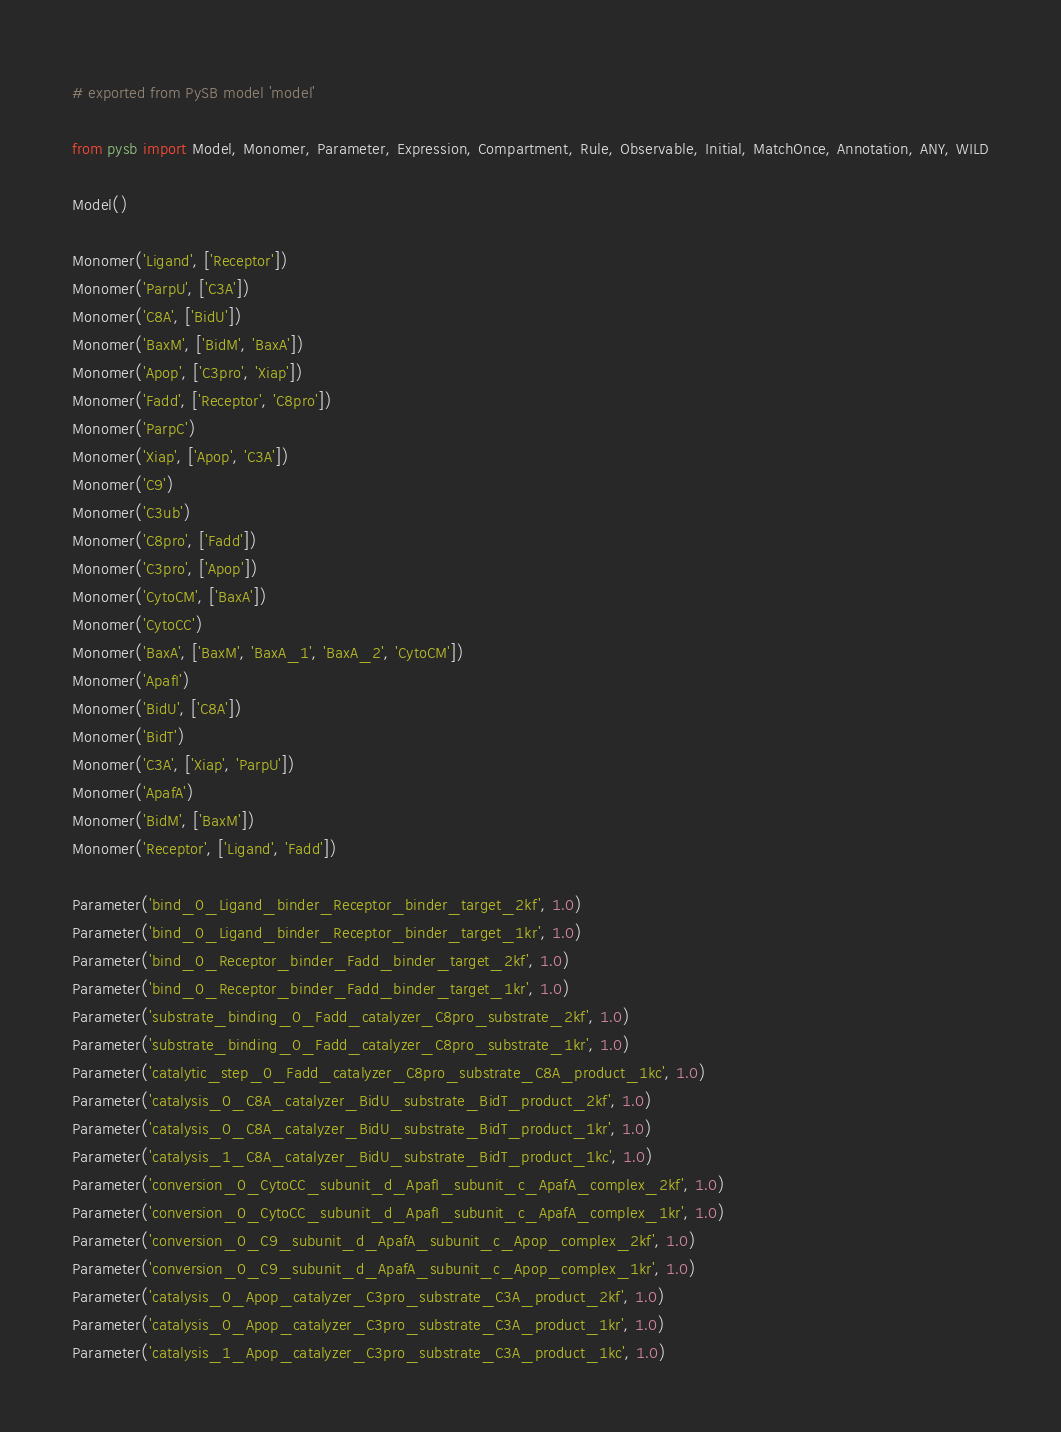<code> <loc_0><loc_0><loc_500><loc_500><_Python_># exported from PySB model 'model'

from pysb import Model, Monomer, Parameter, Expression, Compartment, Rule, Observable, Initial, MatchOnce, Annotation, ANY, WILD

Model()

Monomer('Ligand', ['Receptor'])
Monomer('ParpU', ['C3A'])
Monomer('C8A', ['BidU'])
Monomer('BaxM', ['BidM', 'BaxA'])
Monomer('Apop', ['C3pro', 'Xiap'])
Monomer('Fadd', ['Receptor', 'C8pro'])
Monomer('ParpC')
Monomer('Xiap', ['Apop', 'C3A'])
Monomer('C9')
Monomer('C3ub')
Monomer('C8pro', ['Fadd'])
Monomer('C3pro', ['Apop'])
Monomer('CytoCM', ['BaxA'])
Monomer('CytoCC')
Monomer('BaxA', ['BaxM', 'BaxA_1', 'BaxA_2', 'CytoCM'])
Monomer('ApafI')
Monomer('BidU', ['C8A'])
Monomer('BidT')
Monomer('C3A', ['Xiap', 'ParpU'])
Monomer('ApafA')
Monomer('BidM', ['BaxM'])
Monomer('Receptor', ['Ligand', 'Fadd'])

Parameter('bind_0_Ligand_binder_Receptor_binder_target_2kf', 1.0)
Parameter('bind_0_Ligand_binder_Receptor_binder_target_1kr', 1.0)
Parameter('bind_0_Receptor_binder_Fadd_binder_target_2kf', 1.0)
Parameter('bind_0_Receptor_binder_Fadd_binder_target_1kr', 1.0)
Parameter('substrate_binding_0_Fadd_catalyzer_C8pro_substrate_2kf', 1.0)
Parameter('substrate_binding_0_Fadd_catalyzer_C8pro_substrate_1kr', 1.0)
Parameter('catalytic_step_0_Fadd_catalyzer_C8pro_substrate_C8A_product_1kc', 1.0)
Parameter('catalysis_0_C8A_catalyzer_BidU_substrate_BidT_product_2kf', 1.0)
Parameter('catalysis_0_C8A_catalyzer_BidU_substrate_BidT_product_1kr', 1.0)
Parameter('catalysis_1_C8A_catalyzer_BidU_substrate_BidT_product_1kc', 1.0)
Parameter('conversion_0_CytoCC_subunit_d_ApafI_subunit_c_ApafA_complex_2kf', 1.0)
Parameter('conversion_0_CytoCC_subunit_d_ApafI_subunit_c_ApafA_complex_1kr', 1.0)
Parameter('conversion_0_C9_subunit_d_ApafA_subunit_c_Apop_complex_2kf', 1.0)
Parameter('conversion_0_C9_subunit_d_ApafA_subunit_c_Apop_complex_1kr', 1.0)
Parameter('catalysis_0_Apop_catalyzer_C3pro_substrate_C3A_product_2kf', 1.0)
Parameter('catalysis_0_Apop_catalyzer_C3pro_substrate_C3A_product_1kr', 1.0)
Parameter('catalysis_1_Apop_catalyzer_C3pro_substrate_C3A_product_1kc', 1.0)</code> 